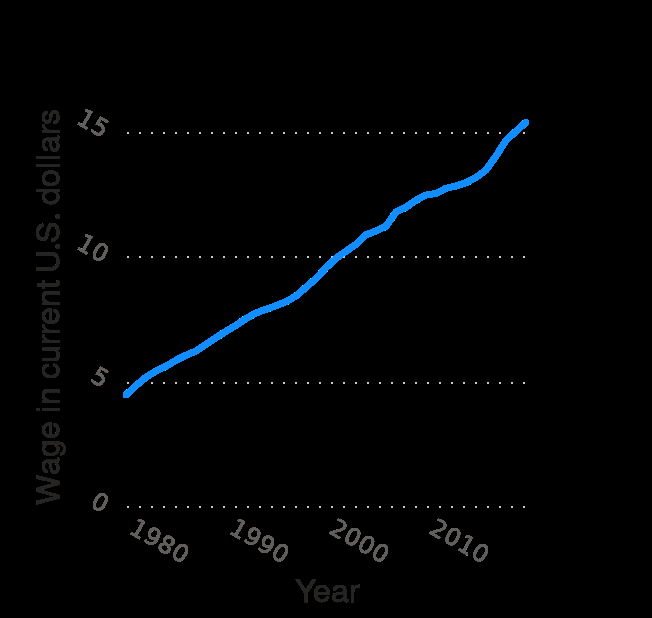<image>
What is the title of the line plot? Median hourly earnings of wage and salary workers in the United States from 1979 to 2019 (in current U.S. dollars). What does the y-axis measure and what is the range? The y-axis measures Wage in current U.S. dollars on a linear scale with a range of 0 to 15. Is the increase in median hourly wage from 1990 to the present considered significant? Yes, considering that it has only doubled in 20 years, the increase in median hourly wage is quite shocking. Describe the following image in detail Here a line plot is titled Median hourly earnings of wage and salary workers in the United States from 1979 to 2019 (in current U.S. dollars). The y-axis measures Wage in current U.S. dollars on linear scale of range 0 to 15 while the x-axis plots Year with linear scale of range 1980 to 2010. 